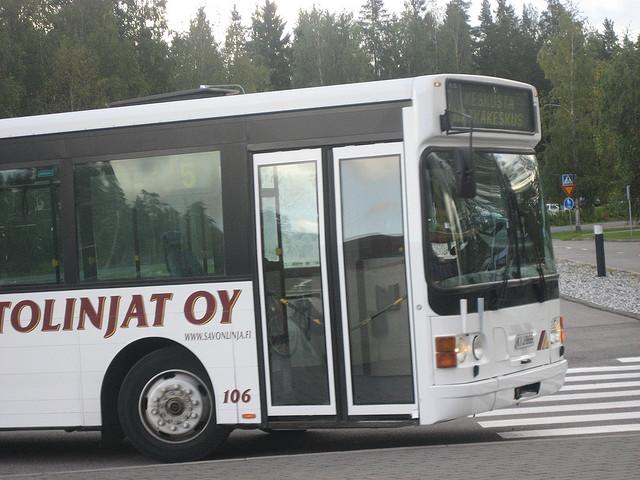Is the bus heading straight forward?
Be succinct. No. What is the website for the bus?
Concise answer only. Wwwsavonlinjafl. Are there any passengers on the bus?
Write a very short answer. No. What number is on the side of this bus?
Concise answer only. 106. 